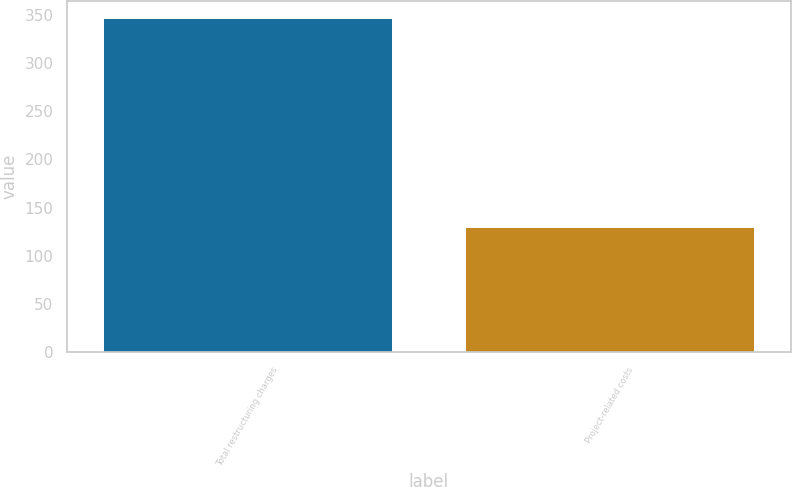Convert chart to OTSL. <chart><loc_0><loc_0><loc_500><loc_500><bar_chart><fcel>Total restructuring charges<fcel>Project-related costs<nl><fcel>347<fcel>130<nl></chart> 